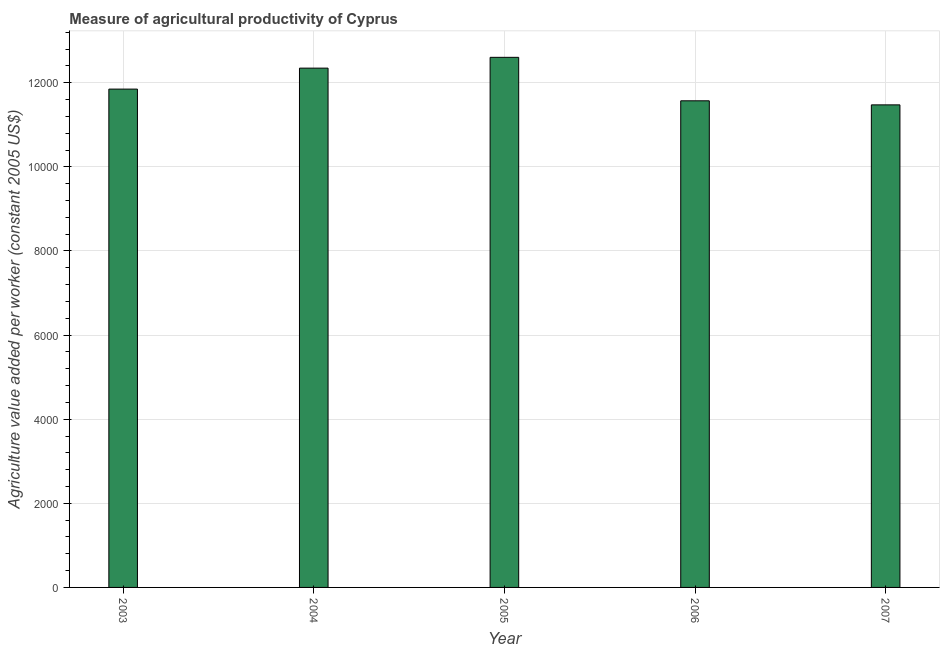Does the graph contain any zero values?
Offer a very short reply. No. What is the title of the graph?
Your answer should be compact. Measure of agricultural productivity of Cyprus. What is the label or title of the X-axis?
Keep it short and to the point. Year. What is the label or title of the Y-axis?
Give a very brief answer. Agriculture value added per worker (constant 2005 US$). What is the agriculture value added per worker in 2003?
Ensure brevity in your answer.  1.18e+04. Across all years, what is the maximum agriculture value added per worker?
Make the answer very short. 1.26e+04. Across all years, what is the minimum agriculture value added per worker?
Offer a very short reply. 1.15e+04. In which year was the agriculture value added per worker maximum?
Offer a very short reply. 2005. In which year was the agriculture value added per worker minimum?
Offer a terse response. 2007. What is the sum of the agriculture value added per worker?
Ensure brevity in your answer.  5.98e+04. What is the difference between the agriculture value added per worker in 2004 and 2005?
Offer a very short reply. -256.86. What is the average agriculture value added per worker per year?
Provide a succinct answer. 1.20e+04. What is the median agriculture value added per worker?
Provide a short and direct response. 1.18e+04. In how many years, is the agriculture value added per worker greater than 4400 US$?
Provide a succinct answer. 5. Do a majority of the years between 2003 and 2005 (inclusive) have agriculture value added per worker greater than 5200 US$?
Offer a very short reply. Yes. What is the ratio of the agriculture value added per worker in 2003 to that in 2007?
Ensure brevity in your answer.  1.03. Is the agriculture value added per worker in 2004 less than that in 2007?
Keep it short and to the point. No. Is the difference between the agriculture value added per worker in 2004 and 2006 greater than the difference between any two years?
Offer a terse response. No. What is the difference between the highest and the second highest agriculture value added per worker?
Your response must be concise. 256.86. Is the sum of the agriculture value added per worker in 2005 and 2006 greater than the maximum agriculture value added per worker across all years?
Provide a succinct answer. Yes. What is the difference between the highest and the lowest agriculture value added per worker?
Offer a very short reply. 1130.49. How many bars are there?
Offer a terse response. 5. How many years are there in the graph?
Ensure brevity in your answer.  5. What is the difference between two consecutive major ticks on the Y-axis?
Make the answer very short. 2000. Are the values on the major ticks of Y-axis written in scientific E-notation?
Your answer should be compact. No. What is the Agriculture value added per worker (constant 2005 US$) in 2003?
Your answer should be compact. 1.18e+04. What is the Agriculture value added per worker (constant 2005 US$) in 2004?
Your answer should be compact. 1.23e+04. What is the Agriculture value added per worker (constant 2005 US$) in 2005?
Keep it short and to the point. 1.26e+04. What is the Agriculture value added per worker (constant 2005 US$) of 2006?
Ensure brevity in your answer.  1.16e+04. What is the Agriculture value added per worker (constant 2005 US$) of 2007?
Give a very brief answer. 1.15e+04. What is the difference between the Agriculture value added per worker (constant 2005 US$) in 2003 and 2004?
Keep it short and to the point. -498.75. What is the difference between the Agriculture value added per worker (constant 2005 US$) in 2003 and 2005?
Offer a very short reply. -755.62. What is the difference between the Agriculture value added per worker (constant 2005 US$) in 2003 and 2006?
Provide a succinct answer. 278.19. What is the difference between the Agriculture value added per worker (constant 2005 US$) in 2003 and 2007?
Your response must be concise. 374.87. What is the difference between the Agriculture value added per worker (constant 2005 US$) in 2004 and 2005?
Offer a very short reply. -256.86. What is the difference between the Agriculture value added per worker (constant 2005 US$) in 2004 and 2006?
Keep it short and to the point. 776.94. What is the difference between the Agriculture value added per worker (constant 2005 US$) in 2004 and 2007?
Give a very brief answer. 873.63. What is the difference between the Agriculture value added per worker (constant 2005 US$) in 2005 and 2006?
Offer a terse response. 1033.8. What is the difference between the Agriculture value added per worker (constant 2005 US$) in 2005 and 2007?
Keep it short and to the point. 1130.49. What is the difference between the Agriculture value added per worker (constant 2005 US$) in 2006 and 2007?
Provide a succinct answer. 96.68. What is the ratio of the Agriculture value added per worker (constant 2005 US$) in 2003 to that in 2006?
Make the answer very short. 1.02. What is the ratio of the Agriculture value added per worker (constant 2005 US$) in 2003 to that in 2007?
Give a very brief answer. 1.03. What is the ratio of the Agriculture value added per worker (constant 2005 US$) in 2004 to that in 2005?
Ensure brevity in your answer.  0.98. What is the ratio of the Agriculture value added per worker (constant 2005 US$) in 2004 to that in 2006?
Offer a very short reply. 1.07. What is the ratio of the Agriculture value added per worker (constant 2005 US$) in 2004 to that in 2007?
Make the answer very short. 1.08. What is the ratio of the Agriculture value added per worker (constant 2005 US$) in 2005 to that in 2006?
Provide a short and direct response. 1.09. What is the ratio of the Agriculture value added per worker (constant 2005 US$) in 2005 to that in 2007?
Offer a very short reply. 1.1. What is the ratio of the Agriculture value added per worker (constant 2005 US$) in 2006 to that in 2007?
Your response must be concise. 1.01. 